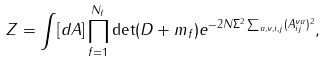Convert formula to latex. <formula><loc_0><loc_0><loc_500><loc_500>Z = \int [ d A ] \prod _ { f = 1 } ^ { N _ { f } } \det ( D + m _ { f } ) e ^ { - 2 N \Sigma ^ { 2 } \sum _ { a , \nu , i , j } ( A _ { i j } ^ { \nu a } ) ^ { 2 } } ,</formula> 